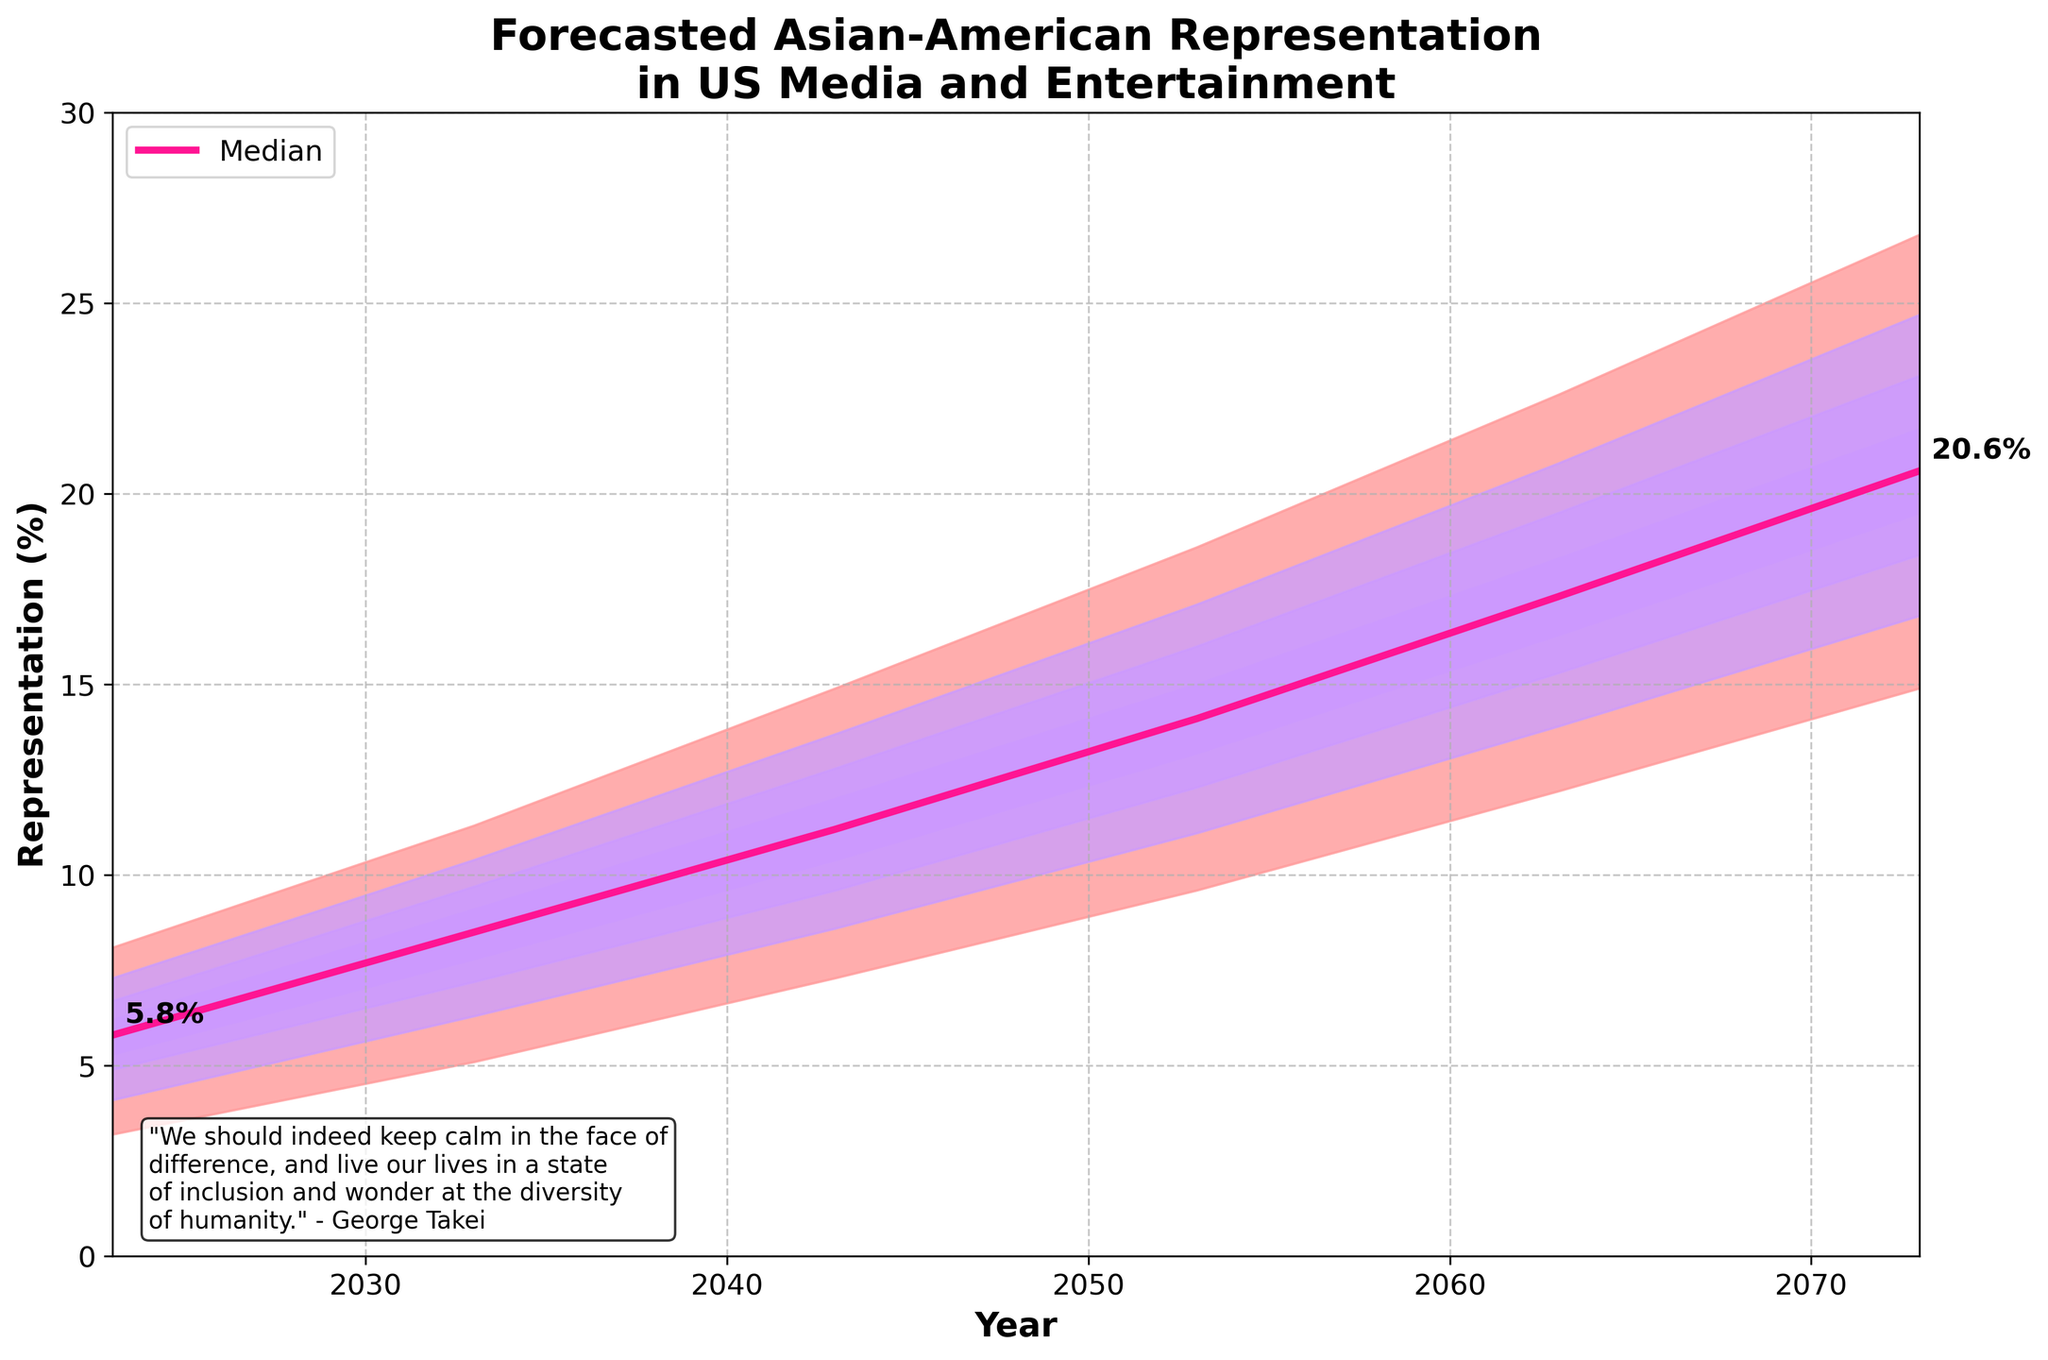What is the title of the plot? The title of the plot is shown at the top of the figure. It is "Forecasted Asian-American Representation in US Media and Entertainment".
Answer: Forecasted Asian-American Representation in US Media and Entertainment What is the median representation in the year 2043? The median representation for each year can be read from the line labeled 'Median'. For the year 2043, it is marked as 11.2%.
Answer: 11.2% Which percentile has the highest value in the year 2073? The plot shows different percentiles with the 90th percentile always having the highest value across all years. In 2073, the 90th percentile reaches up to 26.8%.
Answer: 90th percentile How does the representation change from 2023 to 2073 according to the median? To find the change, subtract the median value in 2023 from the median value in 2073. The values are 20.6% in 2073 and 5.8% in 2023. So the change is 20.6% - 5.8% = 14.8%.
Answer: 14.8% Between which years is there the largest increase in the median representation? Compare the median values in consecutive years and find the largest difference. The increases are 2.7% (2023-2033), 2.7% (2033-2043), 2.9% (2043-2053), 3.2% (2053-2063), and 3.3% (2063-2073). The largest increase is from 2063 to 2073.
Answer: 2063 to 2073 Which year has the narrowest range between the 10th and 90th percentiles? Calculate the range (difference) between the 90th and 10th percentiles for each year. The ranges are 4.9% (2023), 6.2% (2033), 7.6% (2043), 9% (2053), 10.4% (2063), and 11.9% (2073). The narrowest range is in 2023.
Answer: 2023 By how much does the 10th percentile representation increase from 2023 to 2053? The 10th percentile value in 2023 is 3.2%, and in 2053 it is 9.6%. The increase is 9.6% - 3.2% = 6.4%.
Answer: 6.4% What is the range of representation in the year 2063 according to the 40th and 60th percentiles? The 40th percentile is 16.3%, and the 60th percentile is 18.3%. The range is 18.3% - 16.3% = 2%.
Answer: 2% In which year does the median representation first exceed 10%? Look at the median values over the years: 2023 (5.8%), 2033 (8.5%), 2043 (11.2%), 2053 (14.1%), 2063 (17.3%), and 2073 (20.6%). The median first exceeds 10% in 2043.
Answer: 2043 